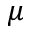Convert formula to latex. <formula><loc_0><loc_0><loc_500><loc_500>\mu</formula> 